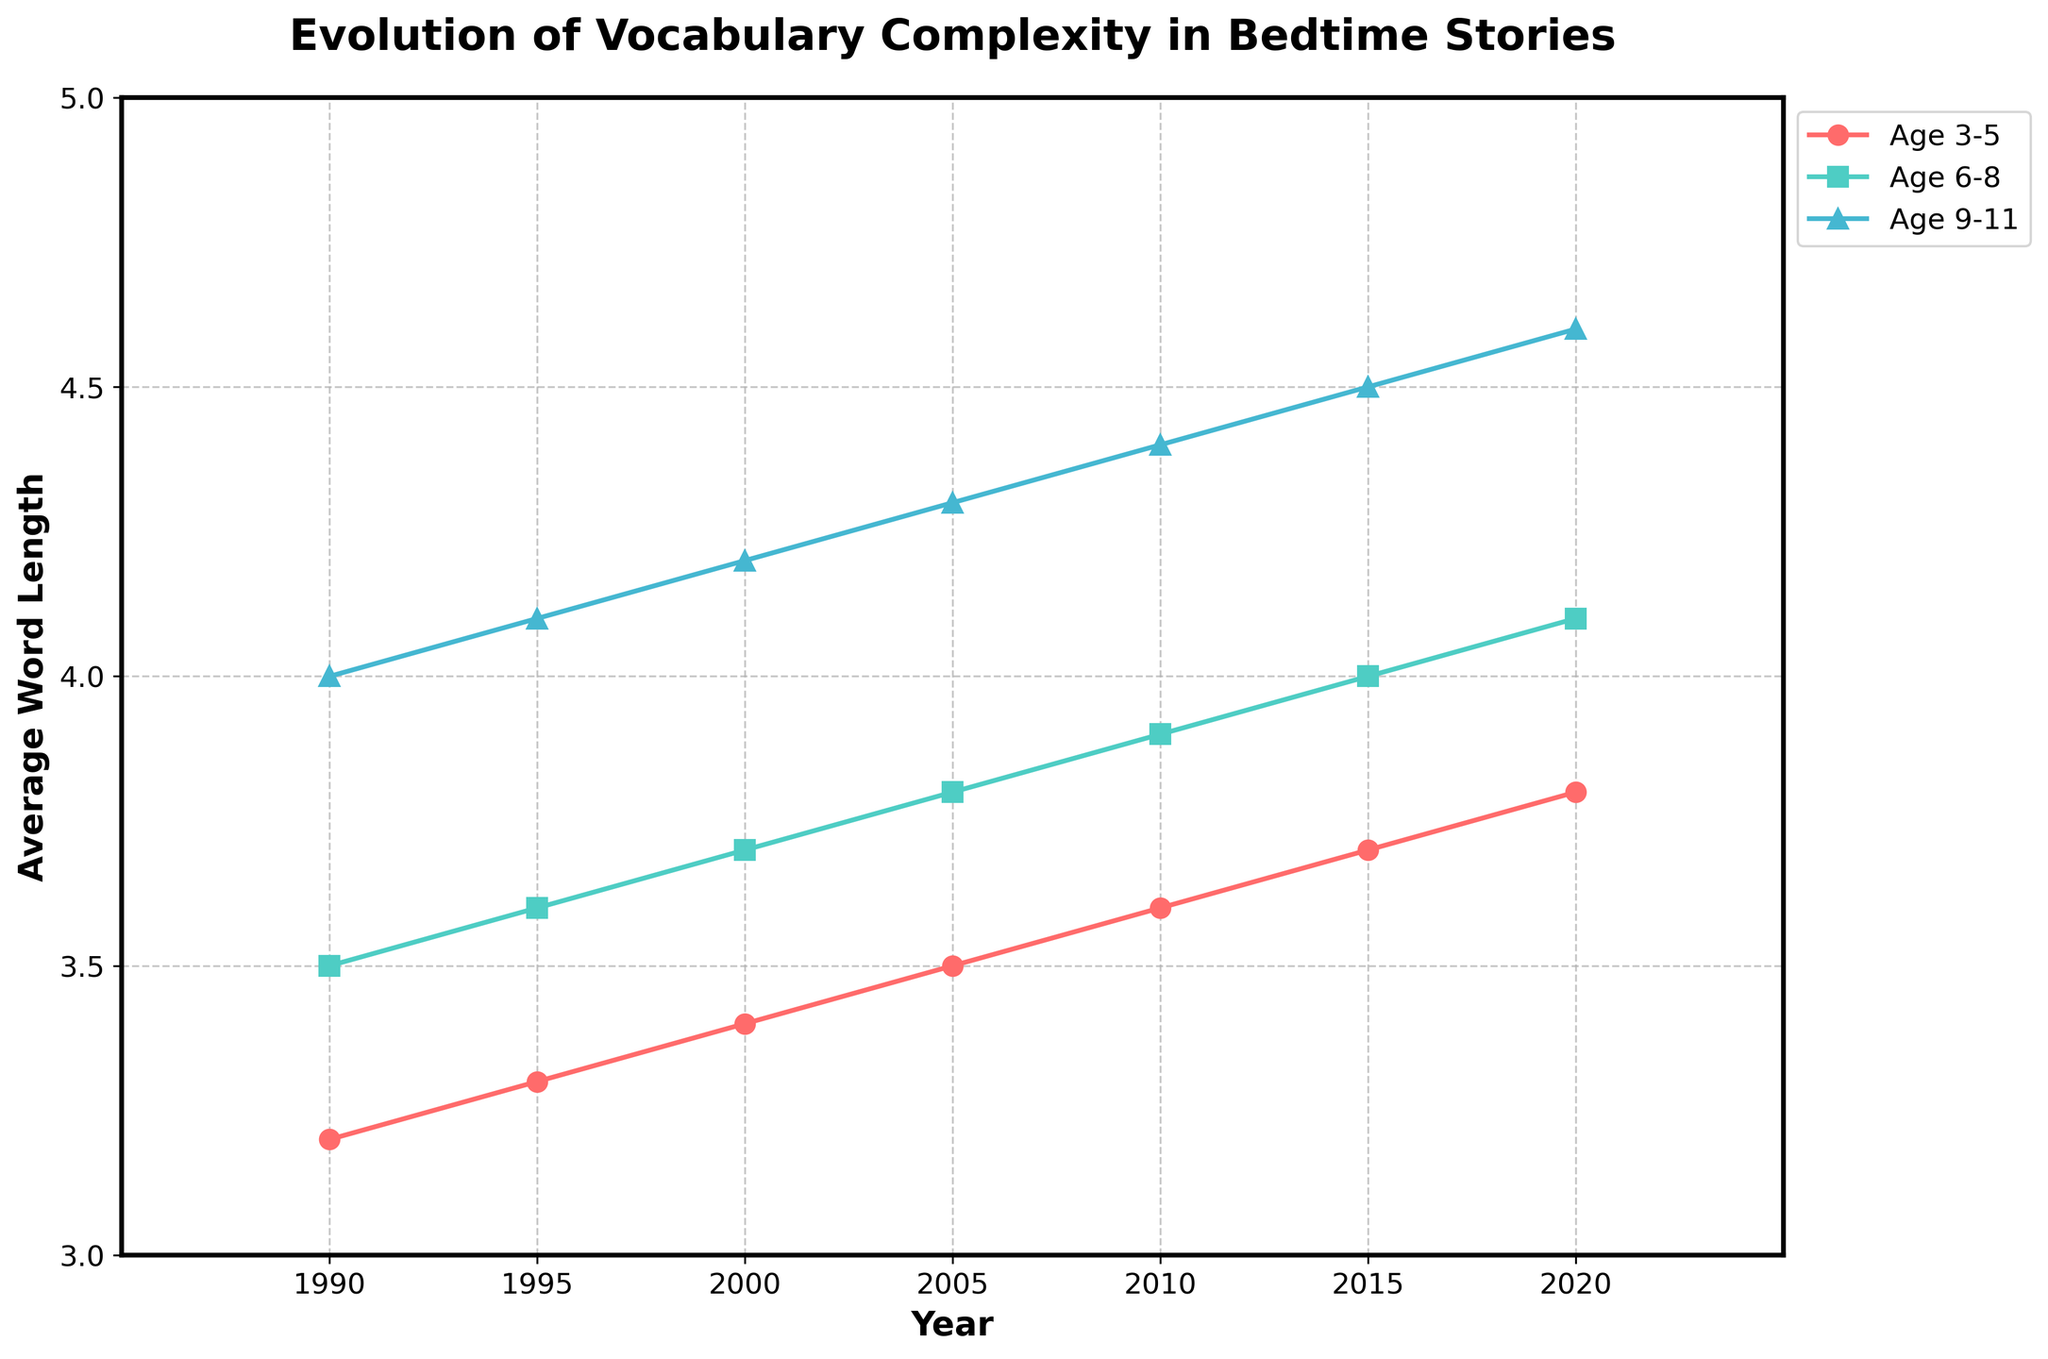What is the average word length for the age group 3-5 in 2000? Look at the plotted data for the age group 3-5 and find the data point corresponding to the year 2000. The average word length is marked at that point.
Answer: 3.4 Which age group had the highest average word length in 2020? Compare the average word lengths of all the age groups (3-5, 6-8, 9-11) in the year 2020 by looking at where each data point is positioned vertically in the plot. The highest value will indicate the age group with the highest average word length.
Answer: 9-11 How did the lexical density for the 9-11 age group change from 1995 to 2005? Lexical density is not plotted but can be inferred from the given data: in 1995, it was 0.57, and in 2005, it was 0.59. Calculate the difference between these two values to determine the change.
Answer: Increased by 0.02 What is the trend of the average word length for the age group 6-8 from 1990 to 2020? Observe the line representing the 6-8 age group in the plot from 1990 to 2020. Note whether the line is increasing, decreasing, or stable.
Answer: Increasing How does the average word length for the age group 3-5 in 1990 compare with the average word length for the age group 9-11 in the same year? Compare the vertical positions of the 1990 data points for the age groups 3-5 and 9-11 to see which is higher.
Answer: 9-11 is higher What is the average increase in word length per year for the age group 6-8 between 1990 and 2020? Calculate the difference in average word length from 1990 to 2020 for the age group 6-8, which is 4.1 - 3.5 = 0.6, and divide by the number of years, 2020 - 1990 = 30, giving the average increase per year.
Answer: 0.02 per year Which age group shows the steepest increase in average word length between 1990 and 2020? Compare the slopes of the lines representing each age group over the years. The line with the steepest slope demonstrates the greatest increase.
Answer: 9-11 How many data points are there for the age group 3-5? Count the number of data points (years) plotted for the age group 3-5.
Answer: 7 In what year did the average word length for the age group 9-11 reach 4.3? Follow the age group 9-11 line and identify the year corresponding to the average word length value 4.3.
Answer: 2005 By how much did the unique words per story for the age group 6-8 increase from 1990 to 2020? The value for unique words per story in 1990 was 75 and in 2020 was 90. Subtract the 1990 value from the 2020 value to get the increase.
Answer: 15 